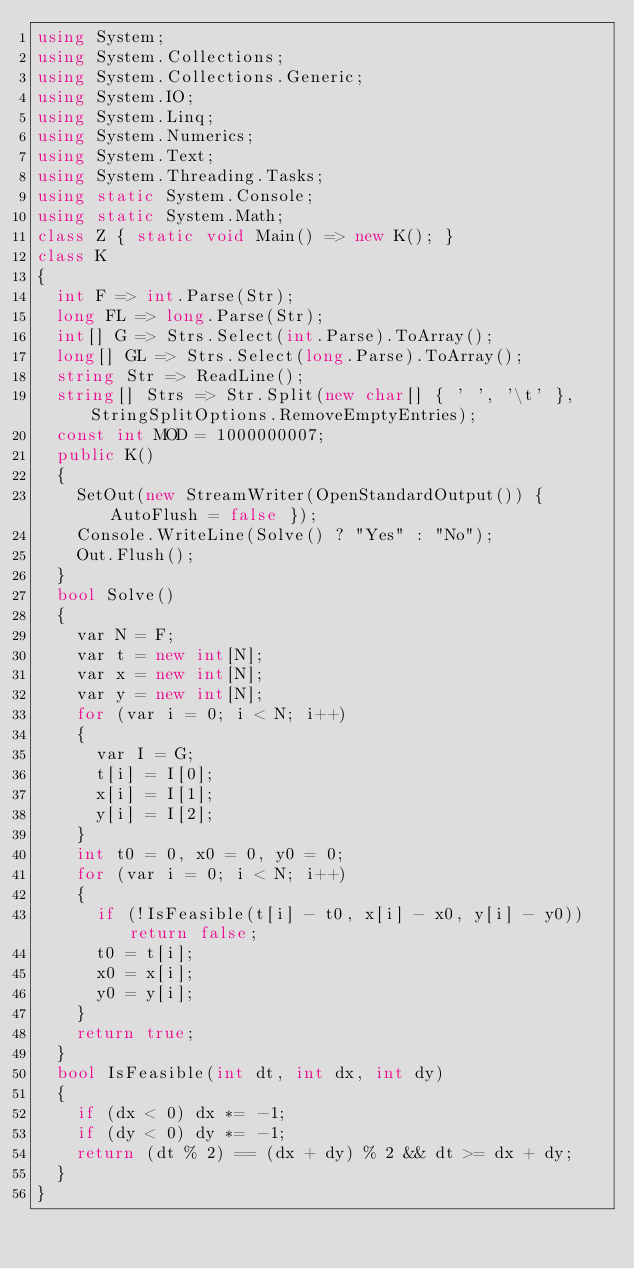<code> <loc_0><loc_0><loc_500><loc_500><_C#_>using System;
using System.Collections;
using System.Collections.Generic;
using System.IO;
using System.Linq;
using System.Numerics;
using System.Text;
using System.Threading.Tasks;
using static System.Console;
using static System.Math;
class Z { static void Main() => new K(); }
class K
{
	int F => int.Parse(Str);
	long FL => long.Parse(Str);
	int[] G => Strs.Select(int.Parse).ToArray();
	long[] GL => Strs.Select(long.Parse).ToArray();
	string Str => ReadLine();
	string[] Strs => Str.Split(new char[] { ' ', '\t' }, StringSplitOptions.RemoveEmptyEntries);
	const int MOD = 1000000007;
	public K()
	{
		SetOut(new StreamWriter(OpenStandardOutput()) { AutoFlush = false });
		Console.WriteLine(Solve() ? "Yes" : "No");
		Out.Flush();
	}
	bool Solve()
	{
		var N = F;
		var t = new int[N];
		var x = new int[N];
		var y = new int[N];
		for (var i = 0; i < N; i++)
		{
			var I = G;
			t[i] = I[0];
			x[i] = I[1];
			y[i] = I[2];
		}
		int t0 = 0, x0 = 0, y0 = 0;
		for (var i = 0; i < N; i++)
		{
			if (!IsFeasible(t[i] - t0, x[i] - x0, y[i] - y0)) return false;
			t0 = t[i];
			x0 = x[i];
			y0 = y[i];
		}
		return true;
	}
	bool IsFeasible(int dt, int dx, int dy)
	{
		if (dx < 0) dx *= -1;
		if (dy < 0) dy *= -1;
		return (dt % 2) == (dx + dy) % 2 && dt >= dx + dy;
	}
}
</code> 